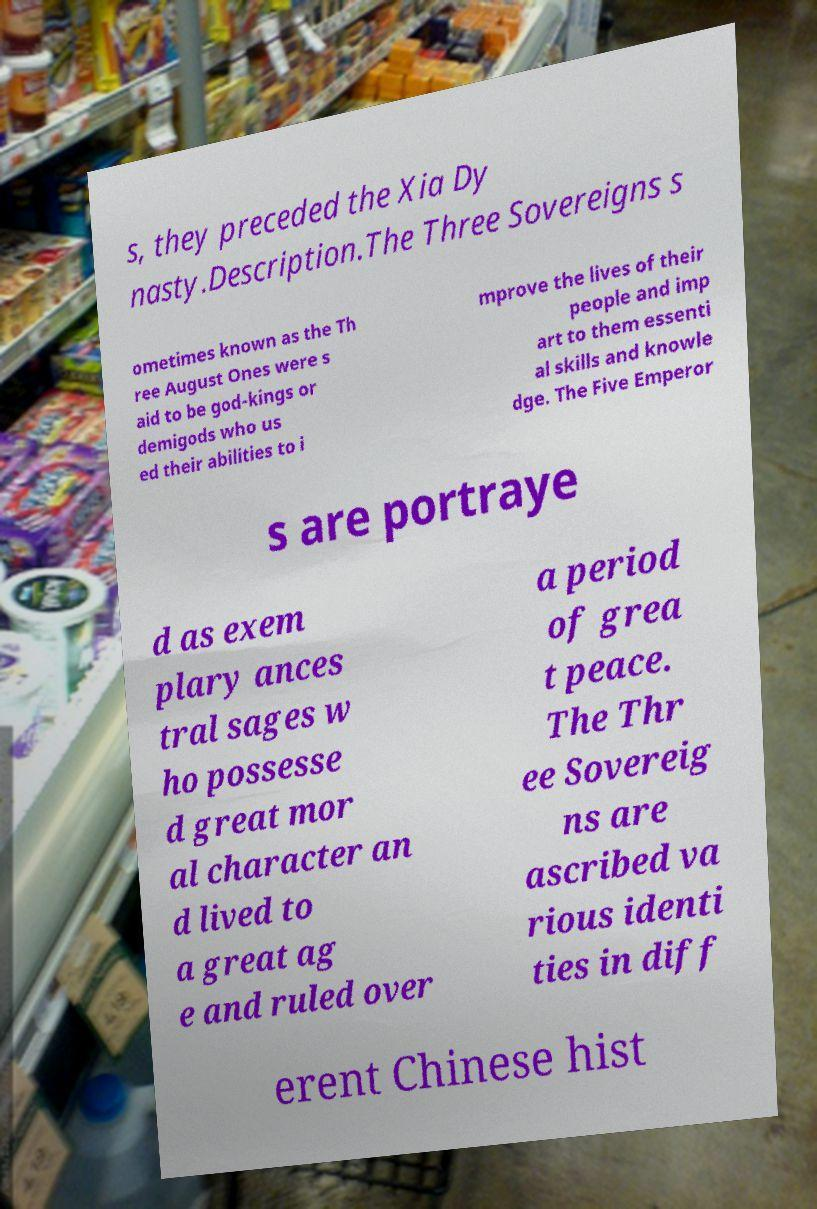Could you extract and type out the text from this image? s, they preceded the Xia Dy nasty.Description.The Three Sovereigns s ometimes known as the Th ree August Ones were s aid to be god-kings or demigods who us ed their abilities to i mprove the lives of their people and imp art to them essenti al skills and knowle dge. The Five Emperor s are portraye d as exem plary ances tral sages w ho possesse d great mor al character an d lived to a great ag e and ruled over a period of grea t peace. The Thr ee Sovereig ns are ascribed va rious identi ties in diff erent Chinese hist 